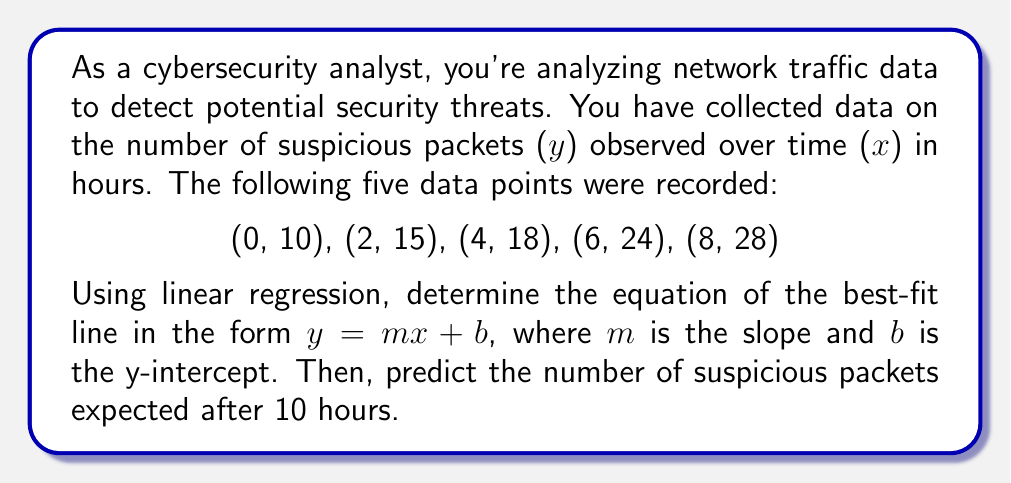Can you solve this math problem? To find the linear regression equation and make a prediction, we'll follow these steps:

1. Calculate the means of x and y:
   $\bar{x} = \frac{0 + 2 + 4 + 6 + 8}{5} = 4$
   $\bar{y} = \frac{10 + 15 + 18 + 24 + 28}{5} = 19$

2. Calculate the slope (m) using the formula:
   $$m = \frac{\sum(x_i - \bar{x})(y_i - \bar{y})}{\sum(x_i - \bar{x})^2}$$

   $\sum(x_i - \bar{x})(y_i - \bar{y}) = (-4)(-9) + (-2)(-4) + (0)(-1) + (2)(5) + (4)(9) = 36 + 8 + 0 + 10 + 36 = 90$
   $\sum(x_i - \bar{x})^2 = (-4)^2 + (-2)^2 + (0)^2 + (2)^2 + (4)^2 = 16 + 4 + 0 + 4 + 16 = 40$

   $m = \frac{90}{40} = 2.25$

3. Calculate the y-intercept (b) using the formula:
   $b = \bar{y} - m\bar{x} = 19 - (2.25)(4) = 19 - 9 = 10$

4. The linear regression equation is:
   $y = 2.25x + 10$

5. To predict the number of suspicious packets after 10 hours, substitute x = 10:
   $y = 2.25(10) + 10 = 22.5 + 10 = 32.5$

Therefore, we expect approximately 33 suspicious packets after 10 hours.
Answer: $y = 2.25x + 10$; 33 packets 